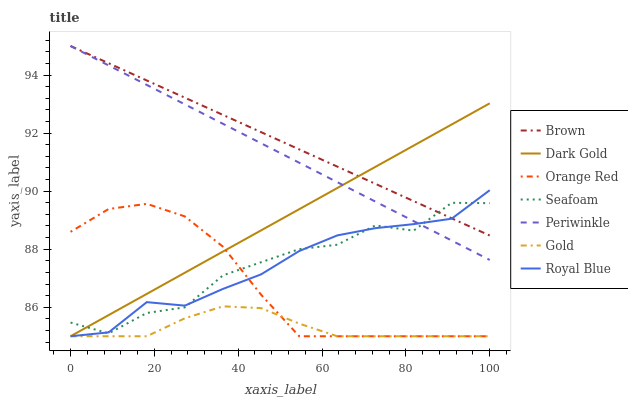Does Gold have the minimum area under the curve?
Answer yes or no. Yes. Does Brown have the maximum area under the curve?
Answer yes or no. Yes. Does Dark Gold have the minimum area under the curve?
Answer yes or no. No. Does Dark Gold have the maximum area under the curve?
Answer yes or no. No. Is Dark Gold the smoothest?
Answer yes or no. Yes. Is Seafoam the roughest?
Answer yes or no. Yes. Is Gold the smoothest?
Answer yes or no. No. Is Gold the roughest?
Answer yes or no. No. Does Gold have the lowest value?
Answer yes or no. Yes. Does Seafoam have the lowest value?
Answer yes or no. No. Does Periwinkle have the highest value?
Answer yes or no. Yes. Does Dark Gold have the highest value?
Answer yes or no. No. Is Gold less than Seafoam?
Answer yes or no. Yes. Is Periwinkle greater than Orange Red?
Answer yes or no. Yes. Does Orange Red intersect Gold?
Answer yes or no. Yes. Is Orange Red less than Gold?
Answer yes or no. No. Is Orange Red greater than Gold?
Answer yes or no. No. Does Gold intersect Seafoam?
Answer yes or no. No. 